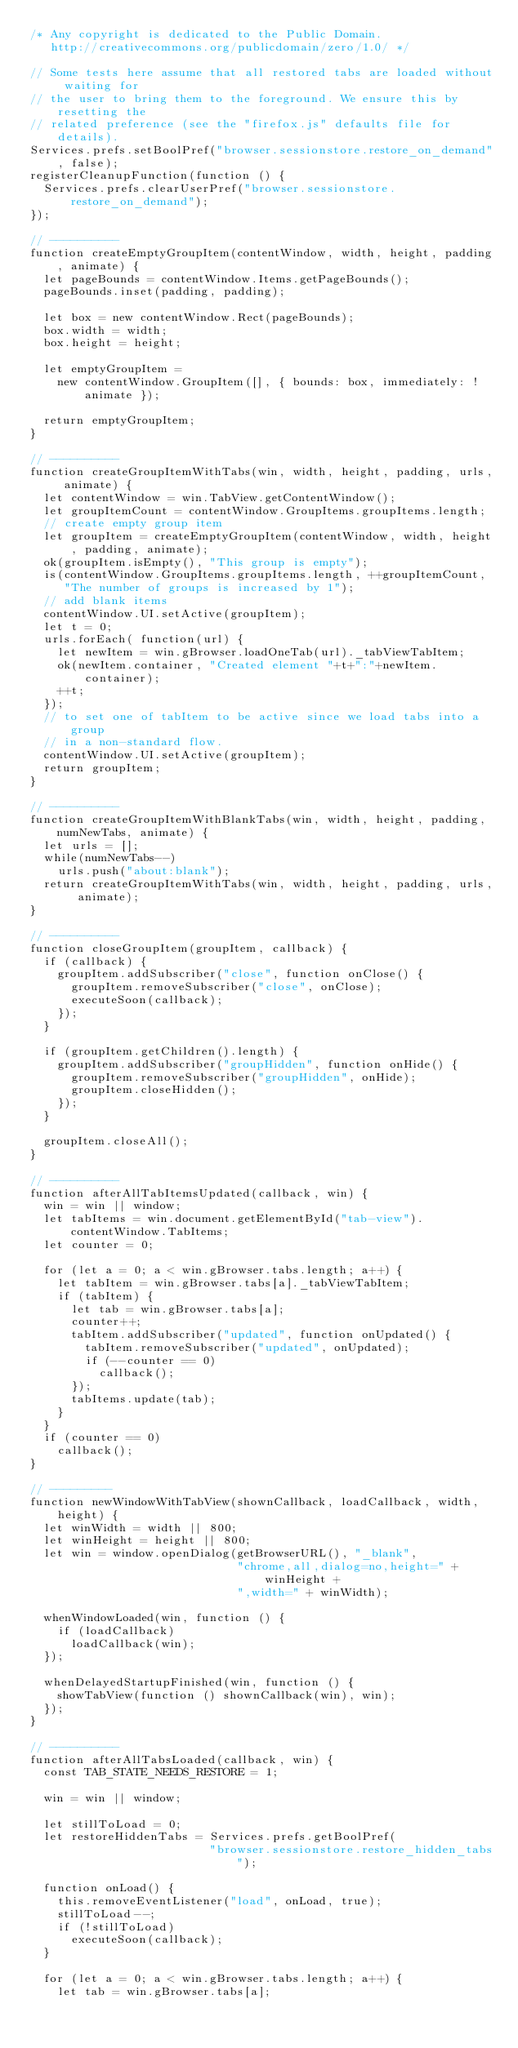<code> <loc_0><loc_0><loc_500><loc_500><_JavaScript_>/* Any copyright is dedicated to the Public Domain.
   http://creativecommons.org/publicdomain/zero/1.0/ */

// Some tests here assume that all restored tabs are loaded without waiting for
// the user to bring them to the foreground. We ensure this by resetting the
// related preference (see the "firefox.js" defaults file for details).
Services.prefs.setBoolPref("browser.sessionstore.restore_on_demand", false);
registerCleanupFunction(function () {
  Services.prefs.clearUserPref("browser.sessionstore.restore_on_demand");
});

// ----------
function createEmptyGroupItem(contentWindow, width, height, padding, animate) {
  let pageBounds = contentWindow.Items.getPageBounds();
  pageBounds.inset(padding, padding);

  let box = new contentWindow.Rect(pageBounds);
  box.width = width;
  box.height = height;

  let emptyGroupItem =
    new contentWindow.GroupItem([], { bounds: box, immediately: !animate });

  return emptyGroupItem;
}

// ----------
function createGroupItemWithTabs(win, width, height, padding, urls, animate) {
  let contentWindow = win.TabView.getContentWindow();
  let groupItemCount = contentWindow.GroupItems.groupItems.length;
  // create empty group item
  let groupItem = createEmptyGroupItem(contentWindow, width, height, padding, animate);
  ok(groupItem.isEmpty(), "This group is empty");
  is(contentWindow.GroupItems.groupItems.length, ++groupItemCount,
     "The number of groups is increased by 1");
  // add blank items
  contentWindow.UI.setActive(groupItem);
  let t = 0;
  urls.forEach( function(url) {
    let newItem = win.gBrowser.loadOneTab(url)._tabViewTabItem;
    ok(newItem.container, "Created element "+t+":"+newItem.container);
    ++t;
  });
  // to set one of tabItem to be active since we load tabs into a group 
  // in a non-standard flow.
  contentWindow.UI.setActive(groupItem);
  return groupItem;
}

// ----------
function createGroupItemWithBlankTabs(win, width, height, padding, numNewTabs, animate) {
  let urls = [];
  while(numNewTabs--)
    urls.push("about:blank");
  return createGroupItemWithTabs(win, width, height, padding, urls, animate);
}

// ----------
function closeGroupItem(groupItem, callback) {
  if (callback) {
    groupItem.addSubscriber("close", function onClose() {
      groupItem.removeSubscriber("close", onClose);
      executeSoon(callback);
    });
  }

  if (groupItem.getChildren().length) {
    groupItem.addSubscriber("groupHidden", function onHide() {
      groupItem.removeSubscriber("groupHidden", onHide);
      groupItem.closeHidden();
    });
  }

  groupItem.closeAll();
}

// ----------
function afterAllTabItemsUpdated(callback, win) {
  win = win || window;
  let tabItems = win.document.getElementById("tab-view").contentWindow.TabItems;
  let counter = 0;

  for (let a = 0; a < win.gBrowser.tabs.length; a++) {
    let tabItem = win.gBrowser.tabs[a]._tabViewTabItem;
    if (tabItem) {
      let tab = win.gBrowser.tabs[a];
      counter++;
      tabItem.addSubscriber("updated", function onUpdated() {
        tabItem.removeSubscriber("updated", onUpdated);
        if (--counter == 0)
          callback();
      });
      tabItems.update(tab);
    }
  }
  if (counter == 0)
    callback();
}

// ---------
function newWindowWithTabView(shownCallback, loadCallback, width, height) {
  let winWidth = width || 800;
  let winHeight = height || 800;
  let win = window.openDialog(getBrowserURL(), "_blank",
                              "chrome,all,dialog=no,height=" + winHeight +
                              ",width=" + winWidth);

  whenWindowLoaded(win, function () {
    if (loadCallback)
      loadCallback(win);
  });

  whenDelayedStartupFinished(win, function () {
    showTabView(function () shownCallback(win), win);
  });
}

// ----------
function afterAllTabsLoaded(callback, win) {
  const TAB_STATE_NEEDS_RESTORE = 1;

  win = win || window;

  let stillToLoad = 0;
  let restoreHiddenTabs = Services.prefs.getBoolPref(
                          "browser.sessionstore.restore_hidden_tabs");

  function onLoad() {
    this.removeEventListener("load", onLoad, true);
    stillToLoad--;
    if (!stillToLoad)
      executeSoon(callback);
  }

  for (let a = 0; a < win.gBrowser.tabs.length; a++) {
    let tab = win.gBrowser.tabs[a];</code> 